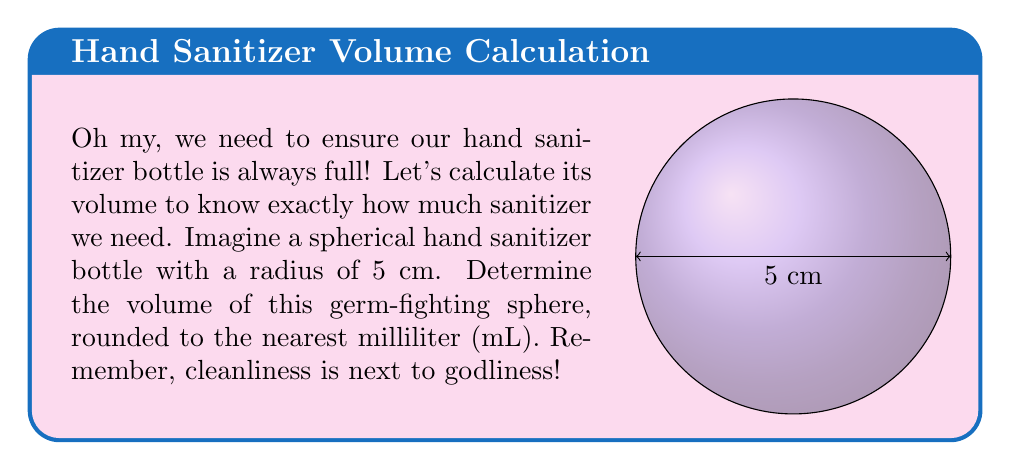Give your solution to this math problem. Let's approach this step-by-step:

1) The formula for the volume of a sphere is:

   $$V = \frac{4}{3}\pi r^3$$

   where $r$ is the radius of the sphere.

2) We're given that the radius is 5 cm. Let's substitute this into our formula:

   $$V = \frac{4}{3}\pi (5\text{ cm})^3$$

3) Let's calculate the cube of 5:

   $$V = \frac{4}{3}\pi (125\text{ cm}^3)$$

4) Now, let's multiply:

   $$V = \frac{500}{3}\pi\text{ cm}^3$$

5) Let's use 3.14159 as an approximation for $\pi$:

   $$V \approx \frac{500}{3} \times 3.14159\text{ cm}^3 \approx 523.5983\text{ cm}^3$$

6) Since 1 cm³ = 1 mL, this is equivalent to 523.5983 mL.

7) Rounding to the nearest milliliter:

   $$V \approx 524\text{ mL}$$

This is how much our germ-fighting sphere can hold!
Answer: 524 mL 